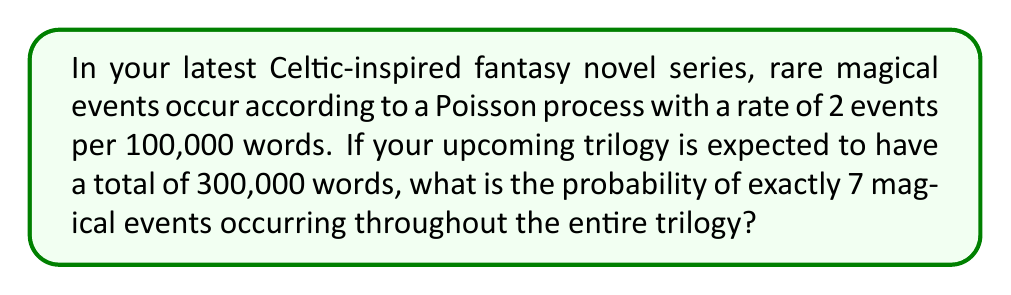Give your solution to this math problem. Let's approach this step-by-step:

1) First, we need to identify the parameters of our Poisson distribution:
   - The rate (λ) is 2 events per 100,000 words
   - The total word count is 300,000 words

2) We need to adjust our rate for the total word count:
   $$ \lambda = 2 \times \frac{300,000}{100,000} = 6 $$

3) Now we have a Poisson distribution with λ = 6, and we want to find P(X = 7)

4) The probability mass function for a Poisson distribution is:

   $$ P(X = k) = \frac{e^{-\lambda}\lambda^k}{k!} $$

5) Plugging in our values:

   $$ P(X = 7) = \frac{e^{-6}6^7}{7!} $$

6) Let's calculate this step-by-step:
   - $e^{-6} \approx 0.00247875$
   - $6^7 = 279,936$
   - $7! = 5,040$

7) Putting it all together:

   $$ \frac{0.00247875 \times 279,936}{5,040} \approx 0.1384 $$

Therefore, the probability of exactly 7 magical events occurring in your trilogy is approximately 0.1384 or 13.84%.
Answer: 0.1384 